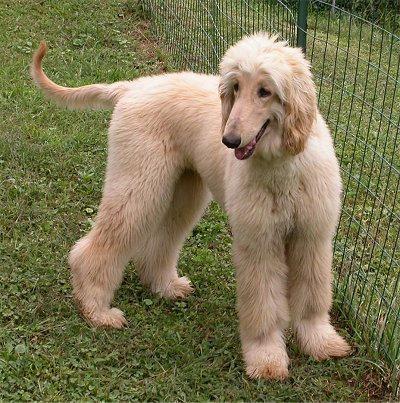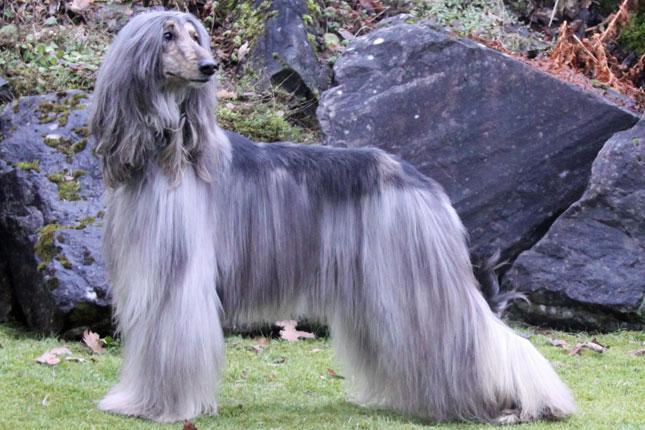The first image is the image on the left, the second image is the image on the right. Analyze the images presented: Is the assertion "An image shows a creamy peach colored hound standing with tail curling upward." valid? Answer yes or no. Yes. The first image is the image on the left, the second image is the image on the right. Analyze the images presented: Is the assertion "Both images show hounds standing with all four paws on the grass." valid? Answer yes or no. Yes. 